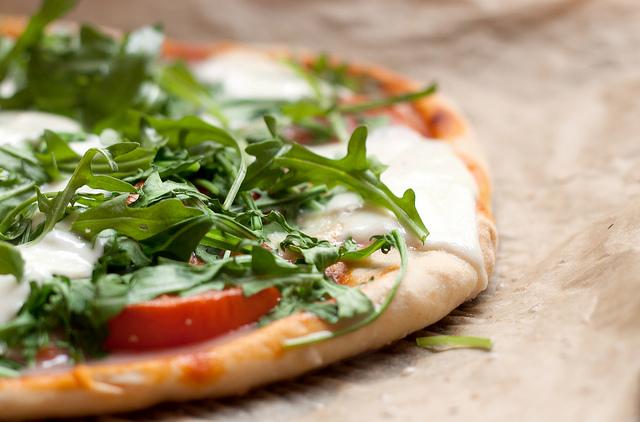What is the red thing on the pizza?
Short answer required. Tomato. Does this picture have a shallow depth of field?
Short answer required. Yes. Do you see sauce?
Quick response, please. Yes. What vegetables are on this pizza?
Be succinct. Tomato. What are the green leaves on the pizza?
Keep it brief. Basil. 